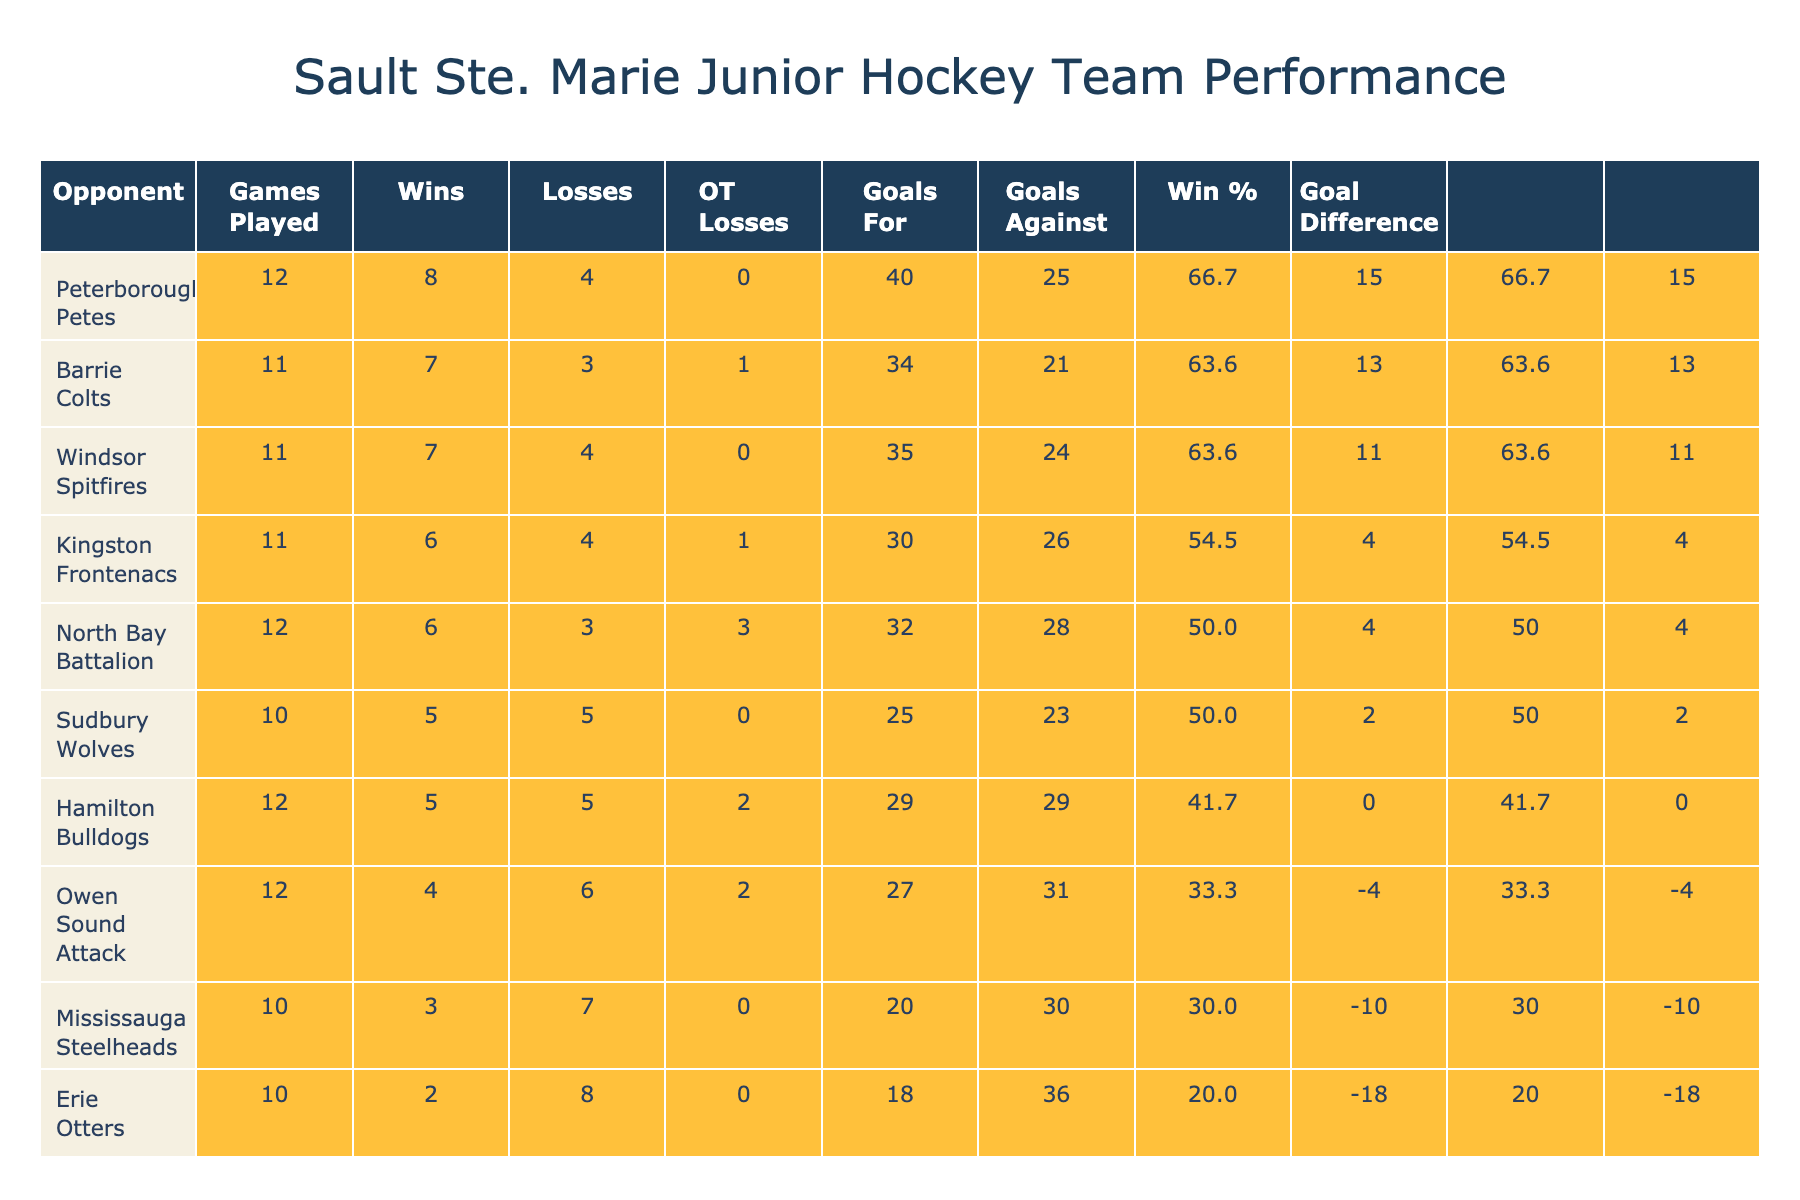What is the win percentage for the Barrie Colts? To find the win percentage for the Barrie Colts, I look at the 'Wins' and 'Games Played' columns for this opponent. The Barrie Colts have 7 wins out of 11 games played. The win percentage is calculated as (7 / 11) * 100 = 63.6%.
Answer: 63.6% Which opponent did the Sault Ste. Marie team have the highest goal difference against? The goal difference is calculated by subtracting 'Goals Against' from 'Goals For'. Checking the goal differences for each opponent, the Barrie Colts have the highest with a difference of 34 (goals for) - 21 (goals against) = 13.
Answer: Barrie Colts Did Sault Ste. Marie have more wins than losses against the Kingston Frontenacs? For the Kingston Frontenacs, the table shows 6 wins and 4 losses. Since the wins (6) are greater than the losses (4), the statement is true.
Answer: Yes What is the total number of games played against the Erie Otters and Mississauga Steelheads combined? To find the total number of games, I add the 'Games Played' for both teams. The Erie Otters have played 10 games and Mississauga Steelheads have played 10 games. So, 10 + 10 = 20 games played combined.
Answer: 20 What was the average goals against for all opponents? To find the average goals against, I sum the 'Goals Against' values for all opponents: 28 + 23 + 21 + 31 + 30 + 25 + 26 + 36 + 29 + 24 =  273. There are 10 opponents, so the average is 273 / 10 = 27.3.
Answer: 27.3 How many teams had the same number of overtime losses as the Sault Ste. Marie team against the Owen Sound Attack? The Owen Sound Attack had 2 overtime losses. Looking through the table, I find two other teams: Hamilton Bulldogs and Peterborough Petes also had 2 overtime losses. Therefore, three teams in total had 2 overtime losses.
Answer: 3 Is it true that the team won more games against the North Bay Battalion than the Sudbury Wolves? The North Bay Battalion has 6 wins and the Sudbury Wolves have 5 wins. Since 6 is greater than 5, the statement is true.
Answer: Yes What is the difference in goals scored between the games played against the highest and lowest-scoring opponents? The highest-scoring opponent is the Peterborough Petes with 40 goals for and the lowest-scoring opponent is the Erie Otters with 18 goals for. The difference is 40 - 18 = 22 goals.
Answer: 22 